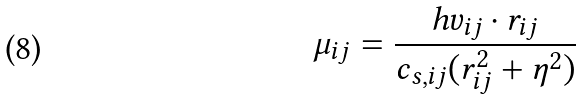Convert formula to latex. <formula><loc_0><loc_0><loc_500><loc_500>\mu _ { i j } = \frac { h v _ { i j } \cdot r _ { i j } } { c _ { s , i j } ( r _ { i j } ^ { 2 } + \eta ^ { 2 } ) }</formula> 